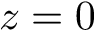<formula> <loc_0><loc_0><loc_500><loc_500>z = 0</formula> 